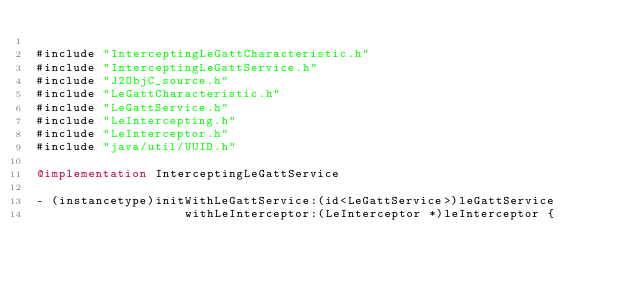Convert code to text. <code><loc_0><loc_0><loc_500><loc_500><_ObjectiveC_>
#include "InterceptingLeGattCharacteristic.h"
#include "InterceptingLeGattService.h"
#include "J2ObjC_source.h"
#include "LeGattCharacteristic.h"
#include "LeGattService.h"
#include "LeIntercepting.h"
#include "LeInterceptor.h"
#include "java/util/UUID.h"

@implementation InterceptingLeGattService

- (instancetype)initWithLeGattService:(id<LeGattService>)leGattService
                    withLeInterceptor:(LeInterceptor *)leInterceptor {</code> 